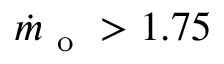Convert formula to latex. <formula><loc_0><loc_0><loc_500><loc_500>\dot { m } _ { o } > 1 . 7 5</formula> 